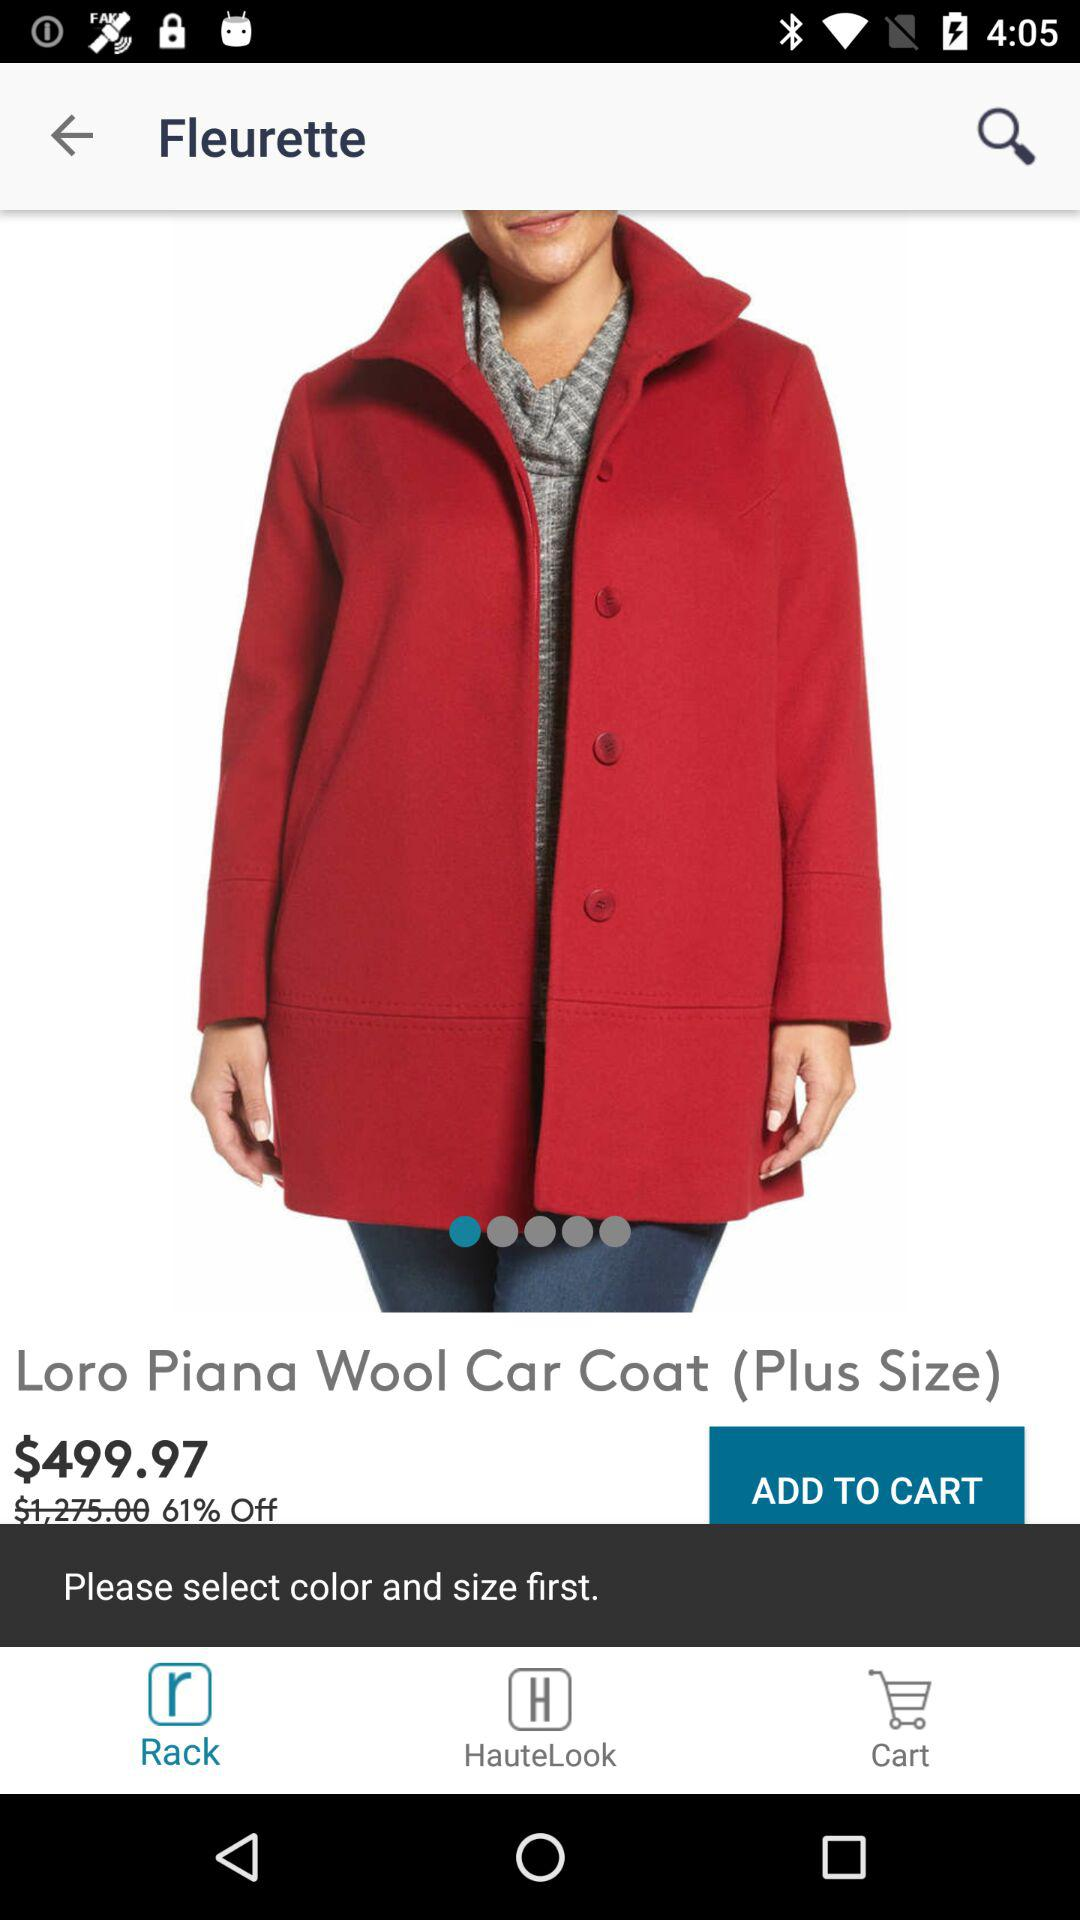What is the price of Wool Car Coat? The price is $499.97. 